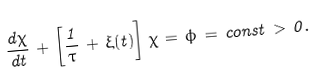Convert formula to latex. <formula><loc_0><loc_0><loc_500><loc_500>\frac { d \chi } { d t } \, + \, \left [ \frac { 1 } { \tau } \, + \, \xi ( t ) \right ] \, \chi \, = \, \phi \, = \, c o n s t \, > \, 0 .</formula> 